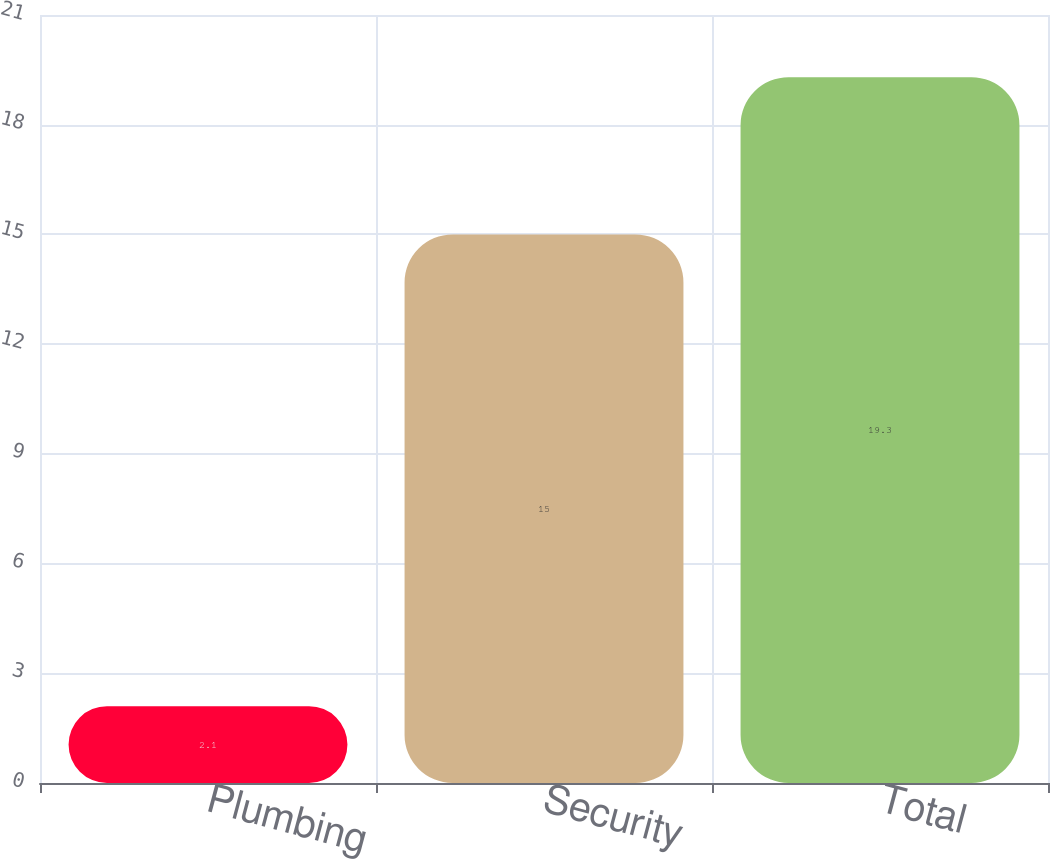<chart> <loc_0><loc_0><loc_500><loc_500><bar_chart><fcel>Plumbing<fcel>Security<fcel>Total<nl><fcel>2.1<fcel>15<fcel>19.3<nl></chart> 